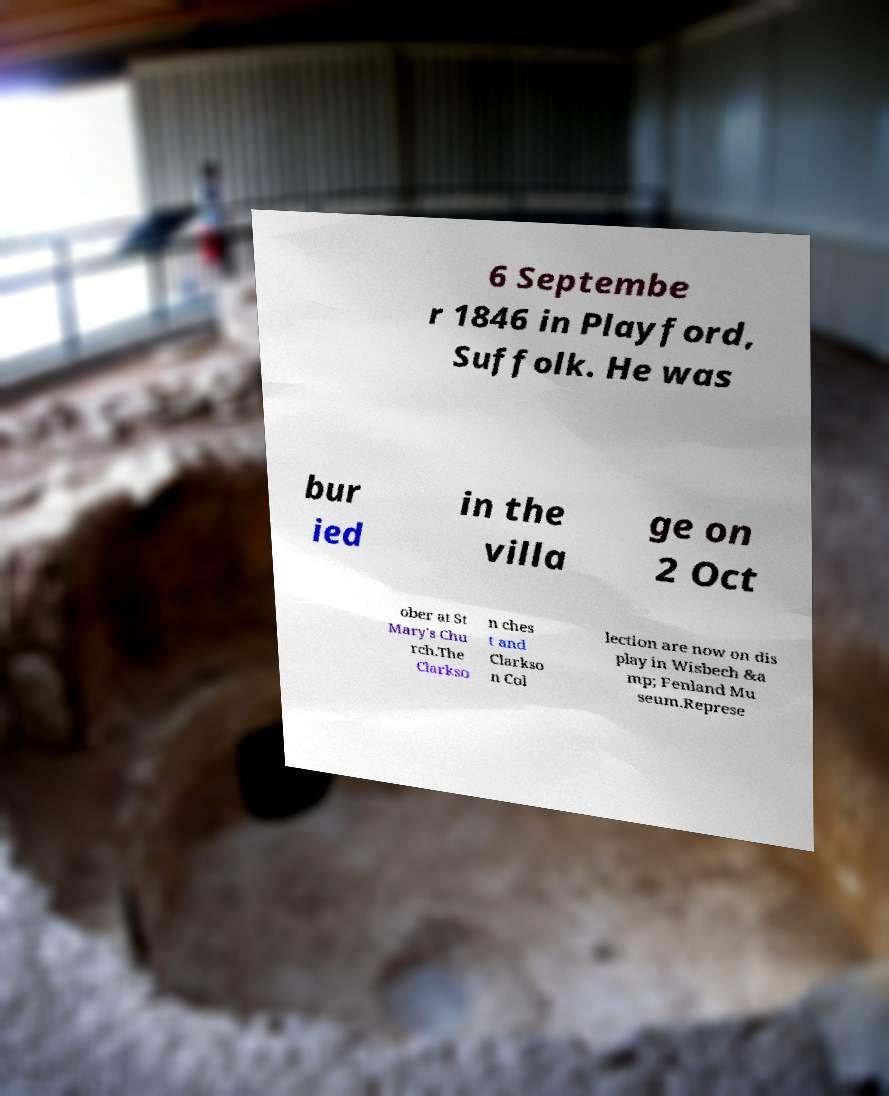Could you extract and type out the text from this image? 6 Septembe r 1846 in Playford, Suffolk. He was bur ied in the villa ge on 2 Oct ober at St Mary's Chu rch.The Clarkso n ches t and Clarkso n Col lection are now on dis play in Wisbech &a mp; Fenland Mu seum.Represe 